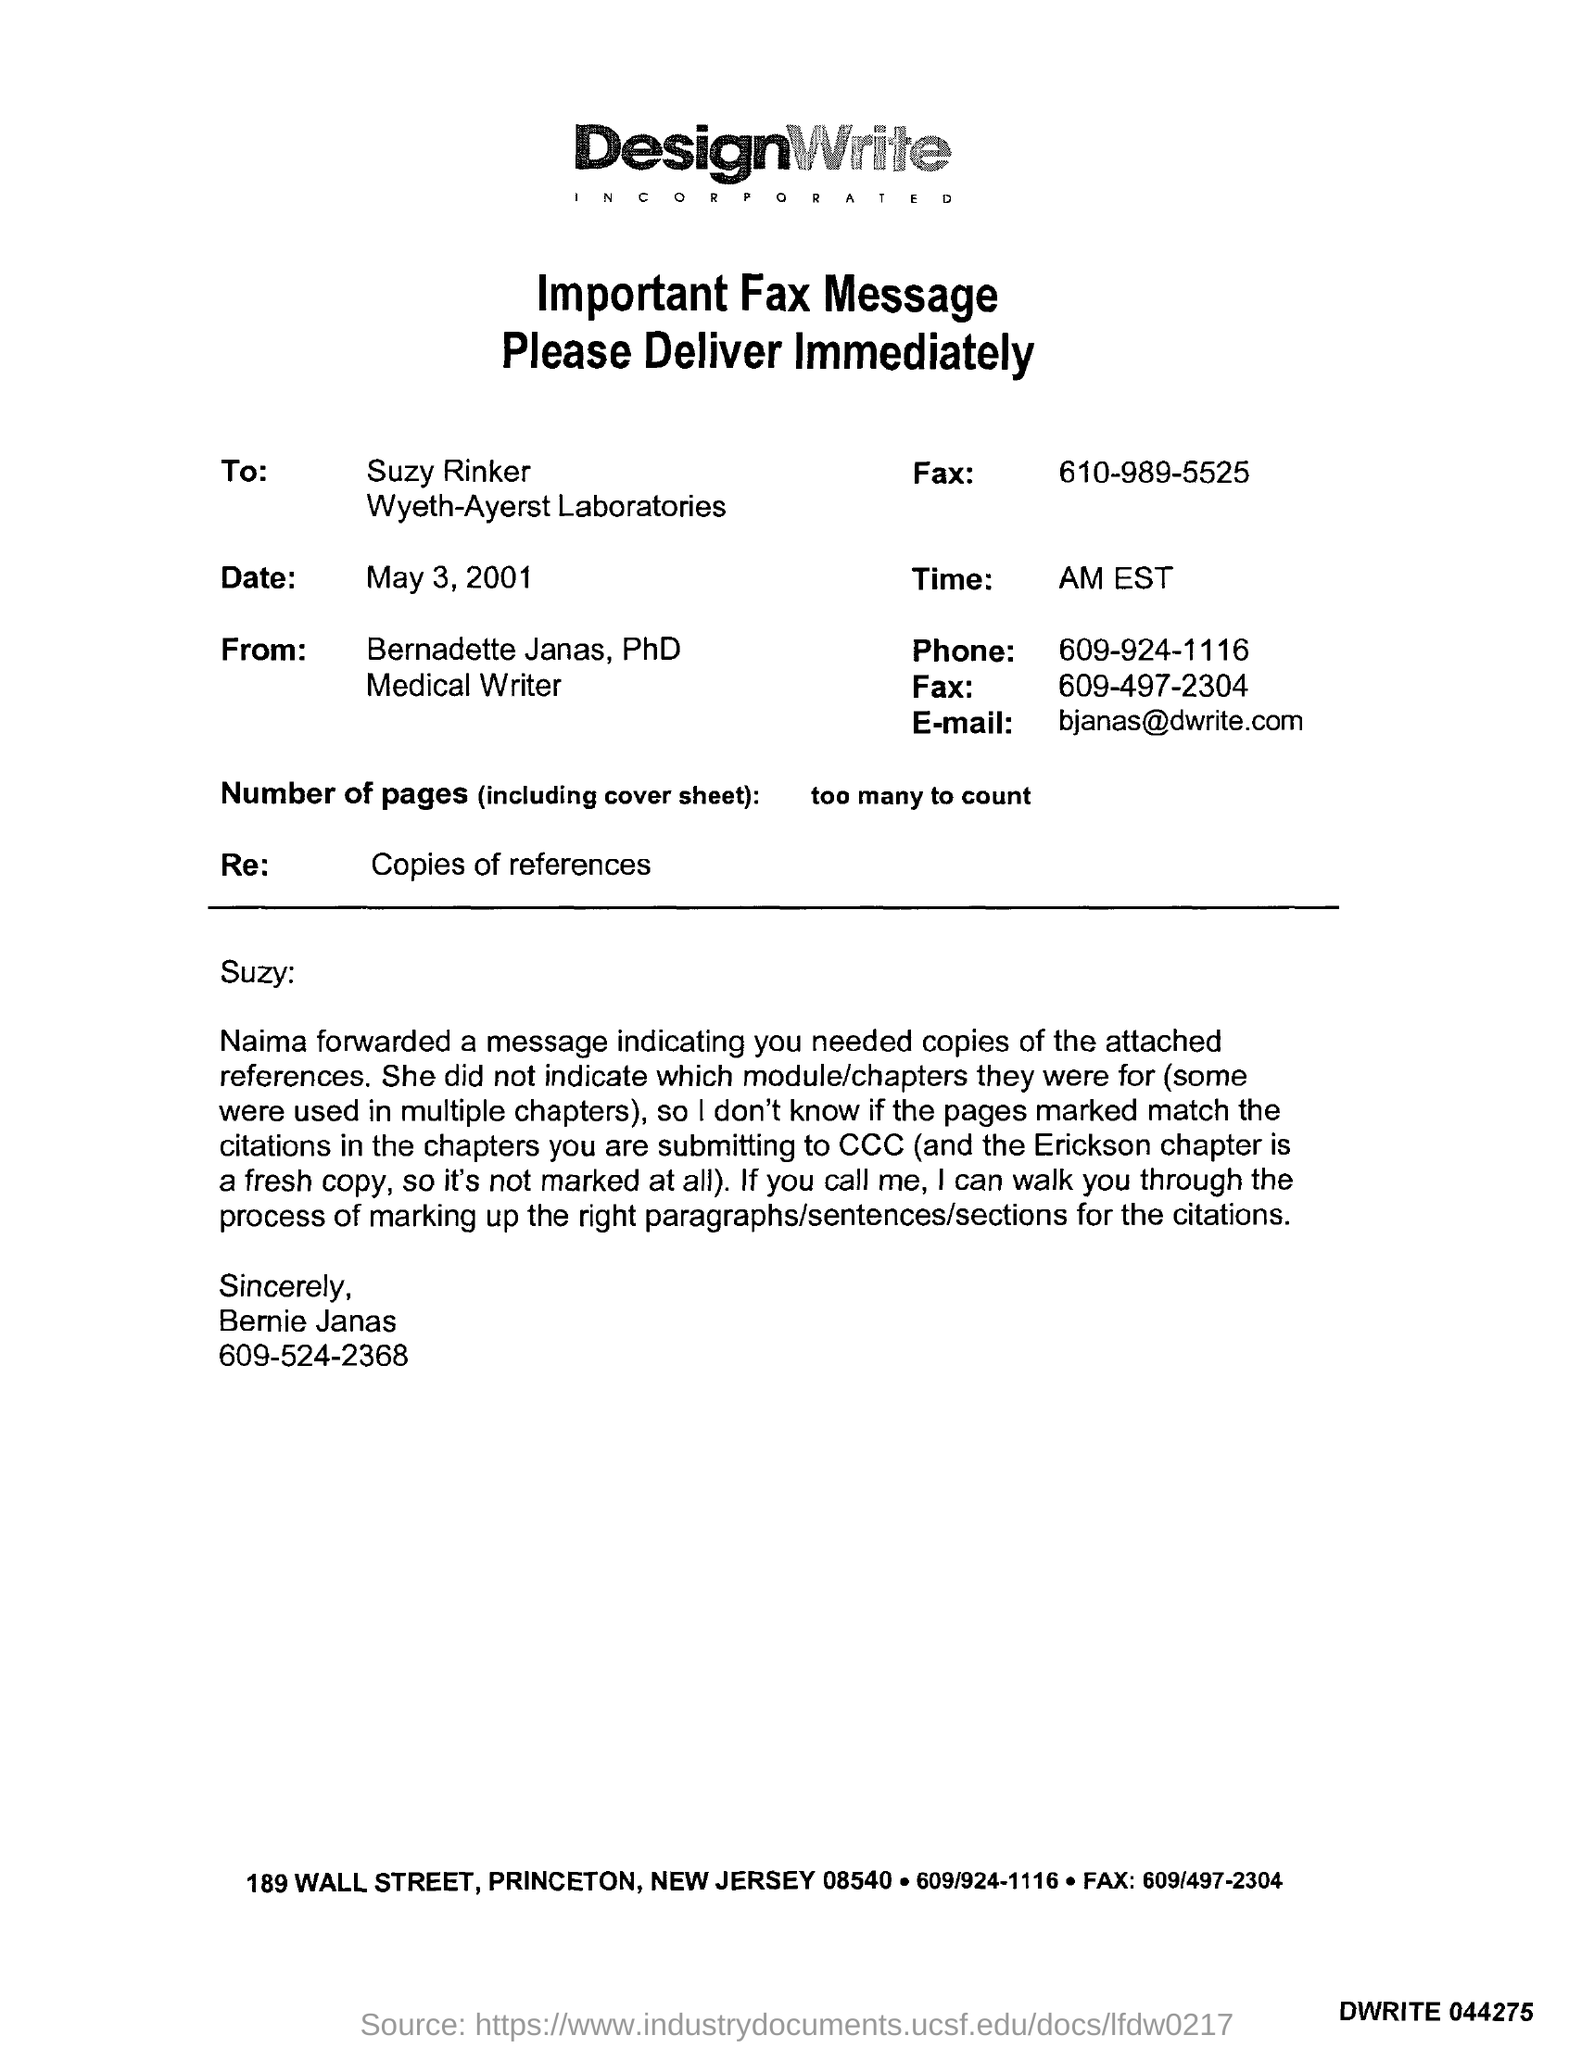Mention a couple of crucial points in this snapshot. The number of pages sent, including the cover page, is too numerous to count. On May 3, 2001, the fax was sent to Suzy Rinker. Wyeth-Ayerst Laboratories is the name of a laboratory. 